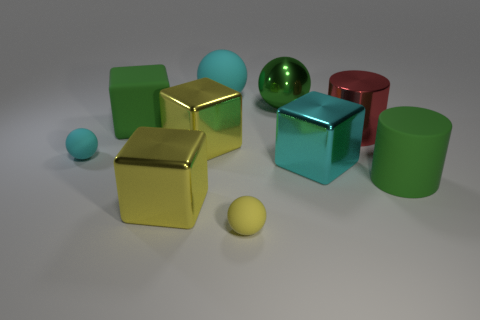Is the number of large red metal cylinders that are left of the green cylinder less than the number of small brown metallic cylinders?
Offer a very short reply. No. How many large yellow metal objects are there?
Offer a terse response. 2. What number of matte cylinders have the same color as the metallic cylinder?
Ensure brevity in your answer.  0. Is the shape of the red thing the same as the tiny yellow matte thing?
Ensure brevity in your answer.  No. There is a yellow object behind the green thing in front of the big cyan cube; how big is it?
Offer a terse response. Large. Is there a green rubber block of the same size as the cyan shiny cube?
Your answer should be compact. Yes. Do the cyan object that is to the right of the tiny yellow rubber thing and the green metal sphere that is to the right of the tiny yellow rubber object have the same size?
Ensure brevity in your answer.  Yes. The green rubber object that is behind the big green thing on the right side of the cyan cube is what shape?
Offer a very short reply. Cube. What number of shiny balls are on the left side of the large red cylinder?
Offer a very short reply. 1. What color is the cylinder that is the same material as the green sphere?
Provide a short and direct response. Red. 